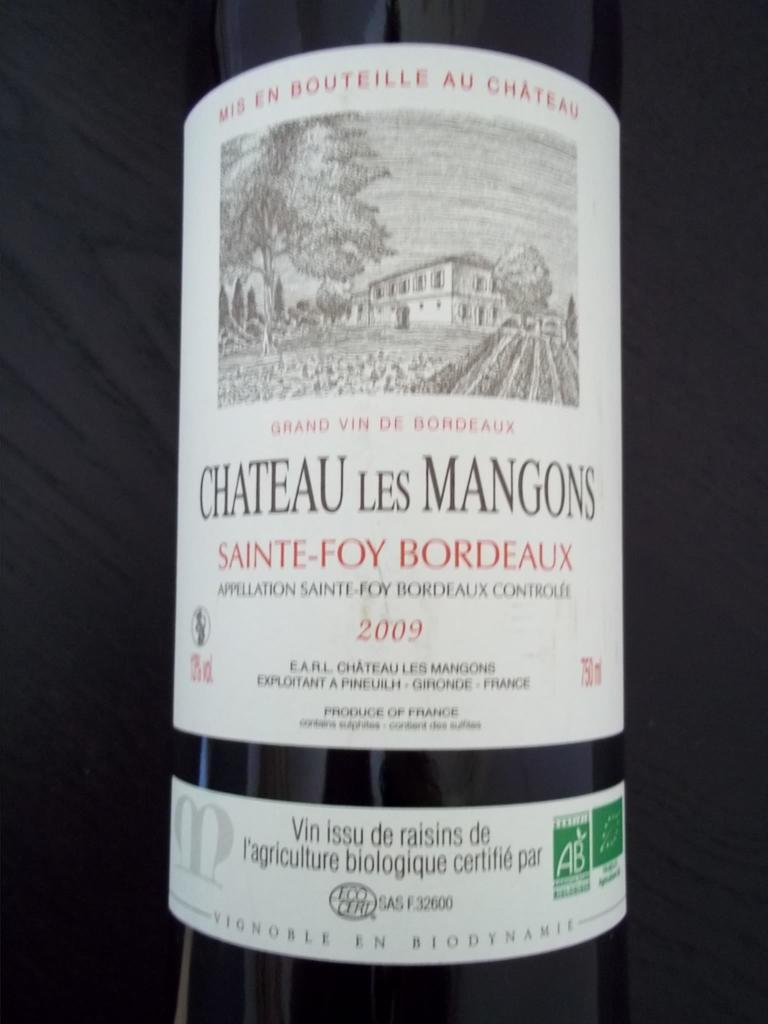<image>
Give a short and clear explanation of the subsequent image. Bottle of Chateau les Mangons sitting on a black background. 